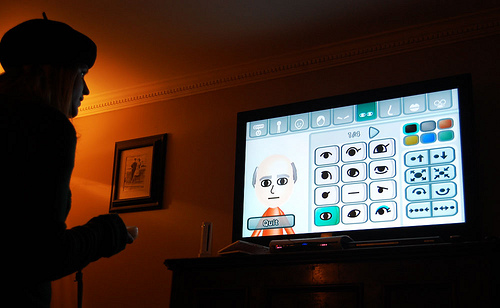Please transcribe the text in this image. Quit 